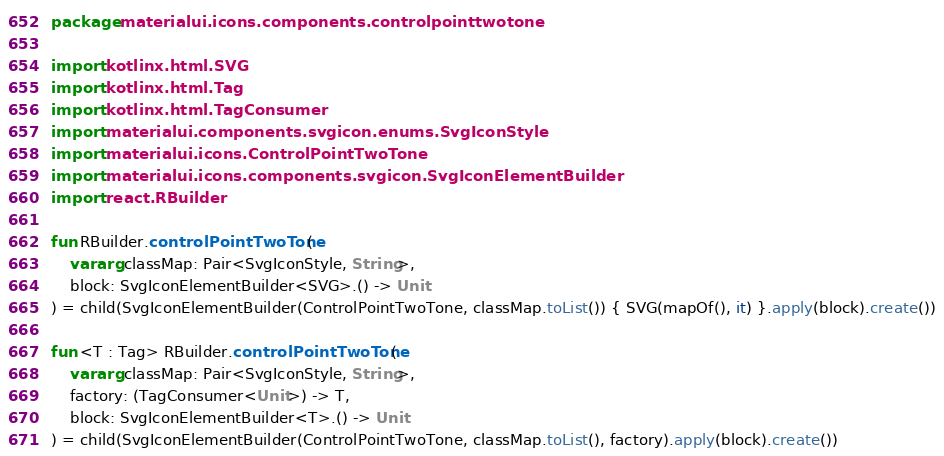Convert code to text. <code><loc_0><loc_0><loc_500><loc_500><_Kotlin_>package materialui.icons.components.controlpointtwotone

import kotlinx.html.SVG
import kotlinx.html.Tag
import kotlinx.html.TagConsumer
import materialui.components.svgicon.enums.SvgIconStyle
import materialui.icons.ControlPointTwoTone
import materialui.icons.components.svgicon.SvgIconElementBuilder
import react.RBuilder

fun RBuilder.controlPointTwoTone(
    vararg classMap: Pair<SvgIconStyle, String>,
    block: SvgIconElementBuilder<SVG>.() -> Unit
) = child(SvgIconElementBuilder(ControlPointTwoTone, classMap.toList()) { SVG(mapOf(), it) }.apply(block).create())

fun <T : Tag> RBuilder.controlPointTwoTone(
    vararg classMap: Pair<SvgIconStyle, String>,
    factory: (TagConsumer<Unit>) -> T,
    block: SvgIconElementBuilder<T>.() -> Unit
) = child(SvgIconElementBuilder(ControlPointTwoTone, classMap.toList(), factory).apply(block).create())
</code> 